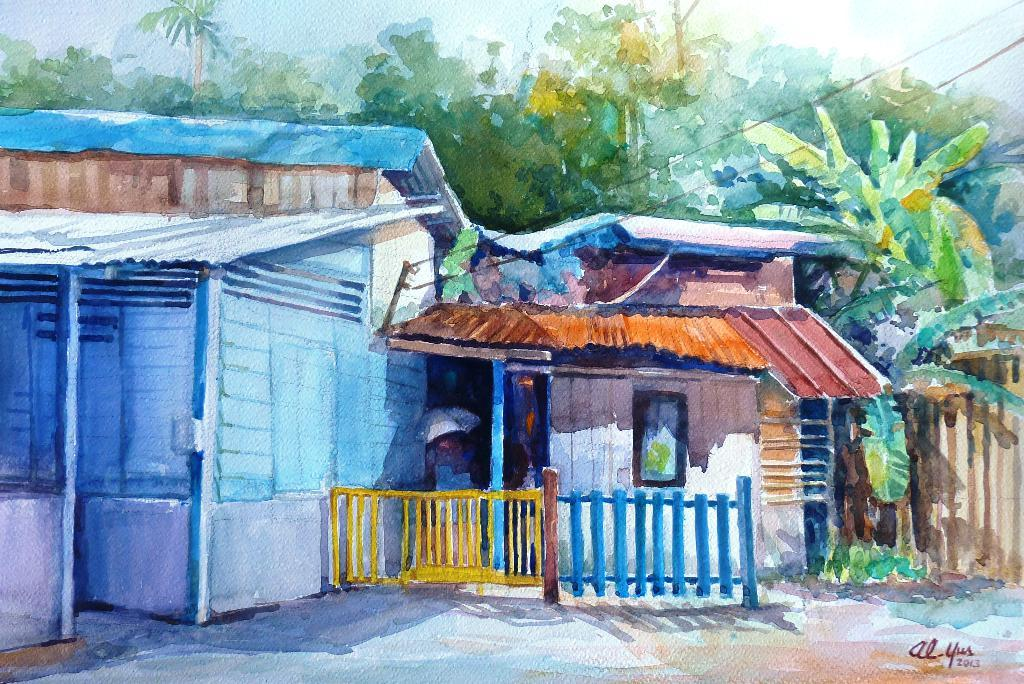What is the main subject of the image? There is a painting in the image. What else can be seen in the image besides the painting? There are buildings and trees in the image. What is the condition of the sky in the image? The sky is clear in the image. How many wishes can be granted by the uncle in the image? There is no uncle present in the image, so it is not possible to determine how many wishes could be granted. 